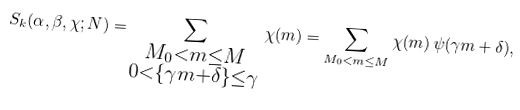Convert formula to latex. <formula><loc_0><loc_0><loc_500><loc_500>S _ { k } ( \alpha , \beta , \chi ; N ) = \sum _ { \substack { M _ { 0 } < m \leq M \\ 0 < \{ \gamma m + \delta \} \leq \gamma } } \chi ( m ) = \sum _ { M _ { 0 } < m \leq M } \chi ( m ) \, \psi ( \gamma m + \delta ) ,</formula> 